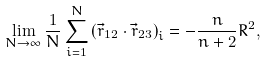Convert formula to latex. <formula><loc_0><loc_0><loc_500><loc_500>\lim _ { N \rightarrow \infty } \frac { 1 } { N } \sum _ { i = 1 } ^ { N } \left ( \vec { r } _ { 1 2 } \cdot \vec { r } _ { 2 3 } \right ) _ { i } = - \frac { n } { n + 2 } R ^ { 2 } ,</formula> 